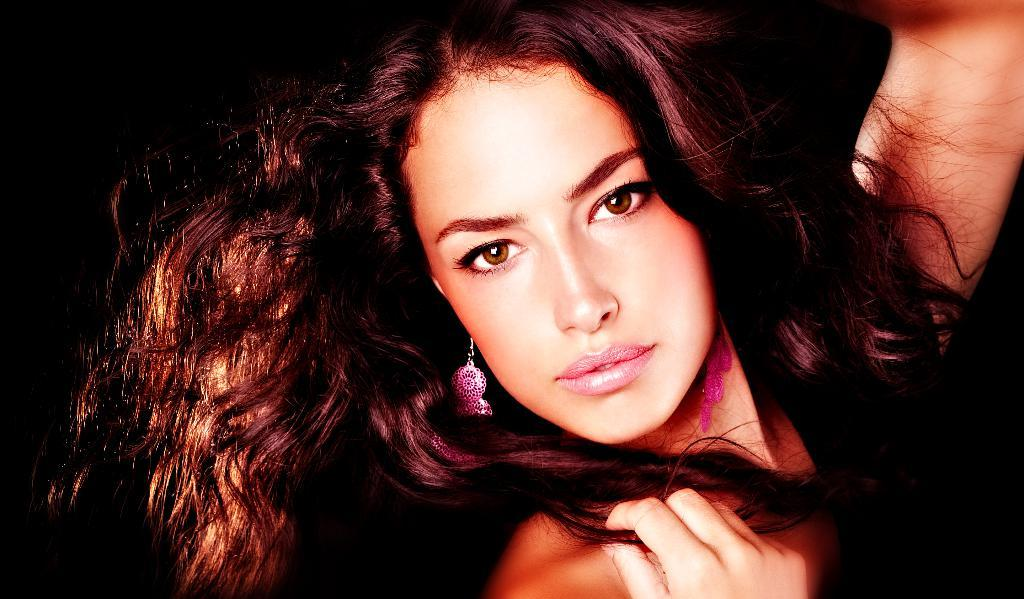Who is the main subject in the picture? There is a woman in the picture. What is the woman wearing in the image? The woman is wearing pink color earrings. Can you describe the woman's hair in the image? The woman has maroon color wavy hair. What is the color of the backdrop in the image? The backdrop of the image is dark. What type of lumber is being sold at the market in the image? There is no market or lumber present in the image; it features a woman with specific details about her appearance and the backdrop. 